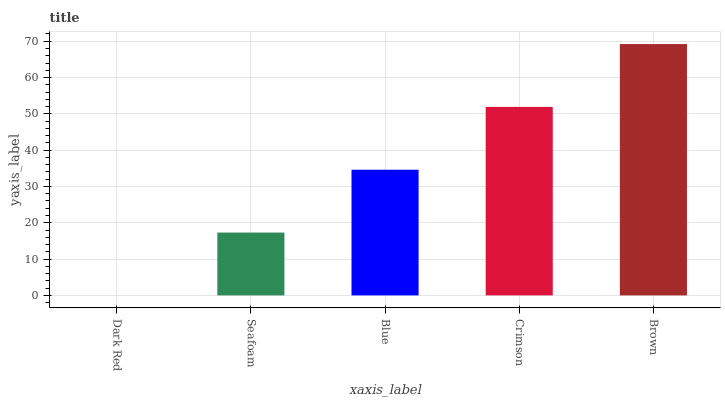Is Seafoam the minimum?
Answer yes or no. No. Is Seafoam the maximum?
Answer yes or no. No. Is Seafoam greater than Dark Red?
Answer yes or no. Yes. Is Dark Red less than Seafoam?
Answer yes or no. Yes. Is Dark Red greater than Seafoam?
Answer yes or no. No. Is Seafoam less than Dark Red?
Answer yes or no. No. Is Blue the high median?
Answer yes or no. Yes. Is Blue the low median?
Answer yes or no. Yes. Is Dark Red the high median?
Answer yes or no. No. Is Seafoam the low median?
Answer yes or no. No. 